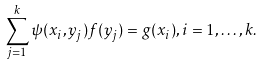Convert formula to latex. <formula><loc_0><loc_0><loc_500><loc_500>\sum _ { j = 1 } ^ { k } \psi ( x _ { i } , y _ { j } ) f ( y _ { j } ) = g ( x _ { i } ) , i = 1 , \dots , k .</formula> 